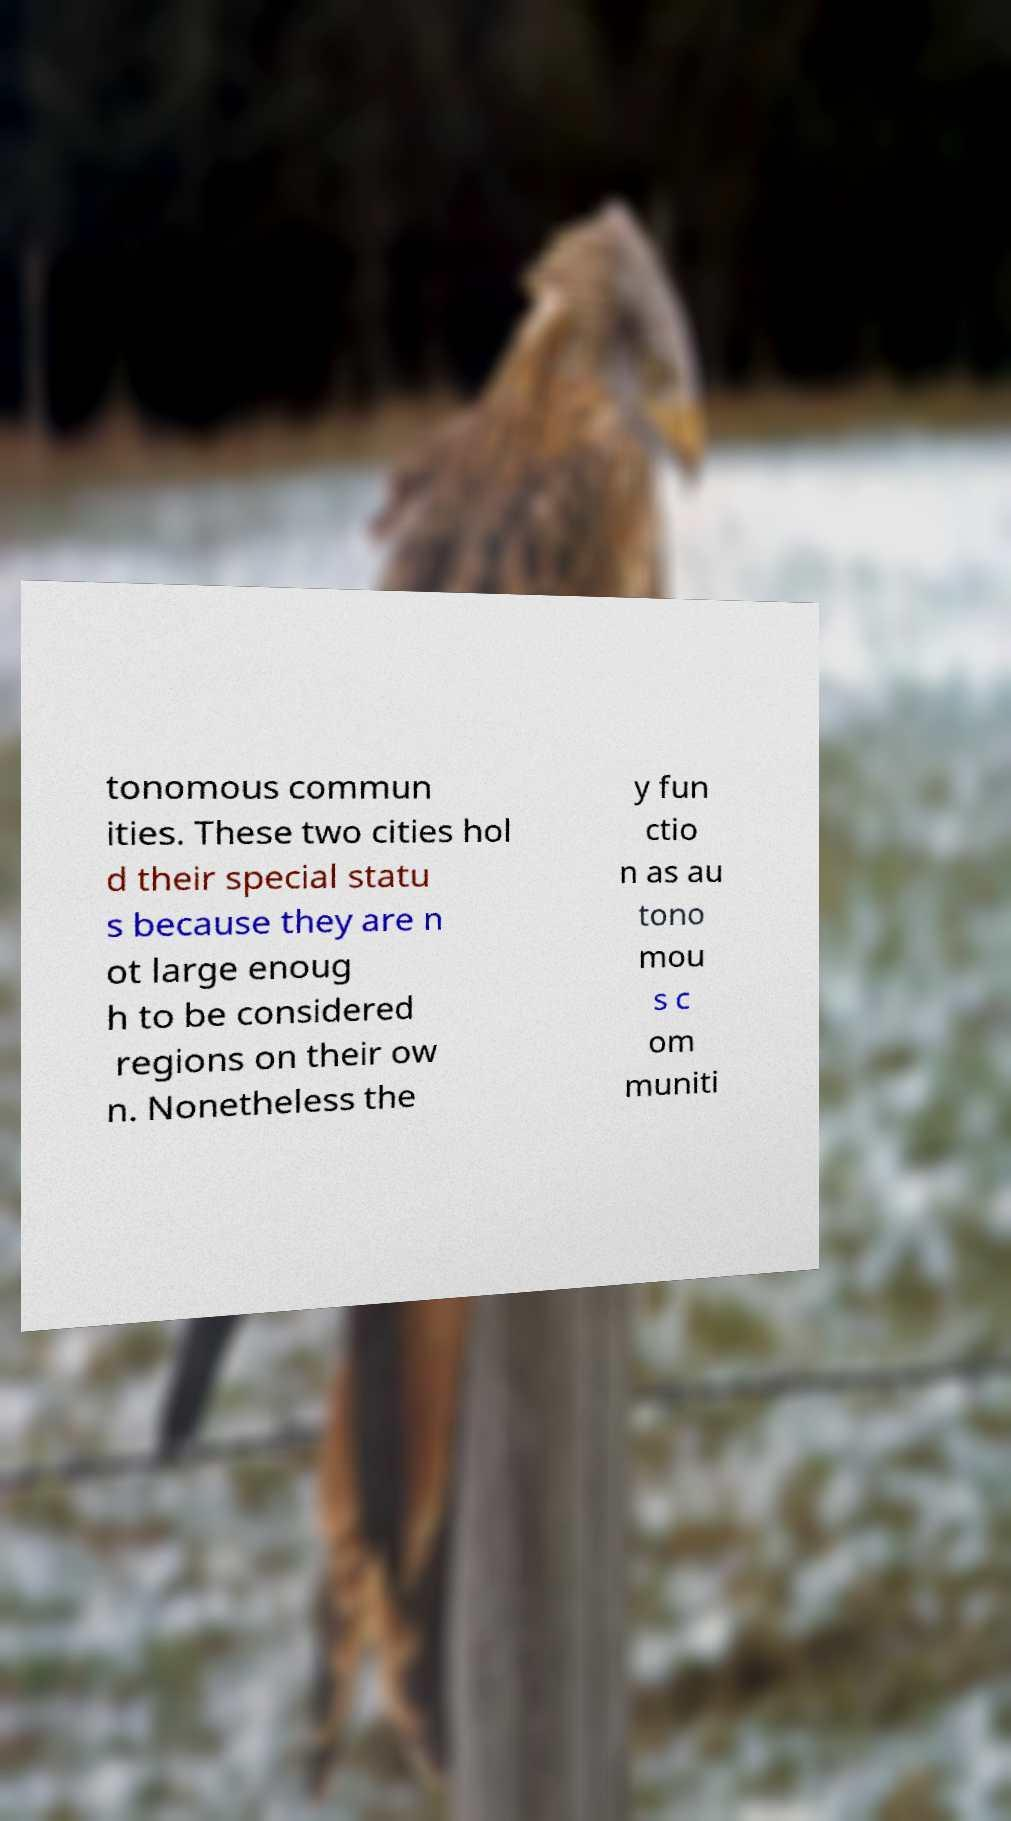Please identify and transcribe the text found in this image. tonomous commun ities. These two cities hol d their special statu s because they are n ot large enoug h to be considered regions on their ow n. Nonetheless the y fun ctio n as au tono mou s c om muniti 